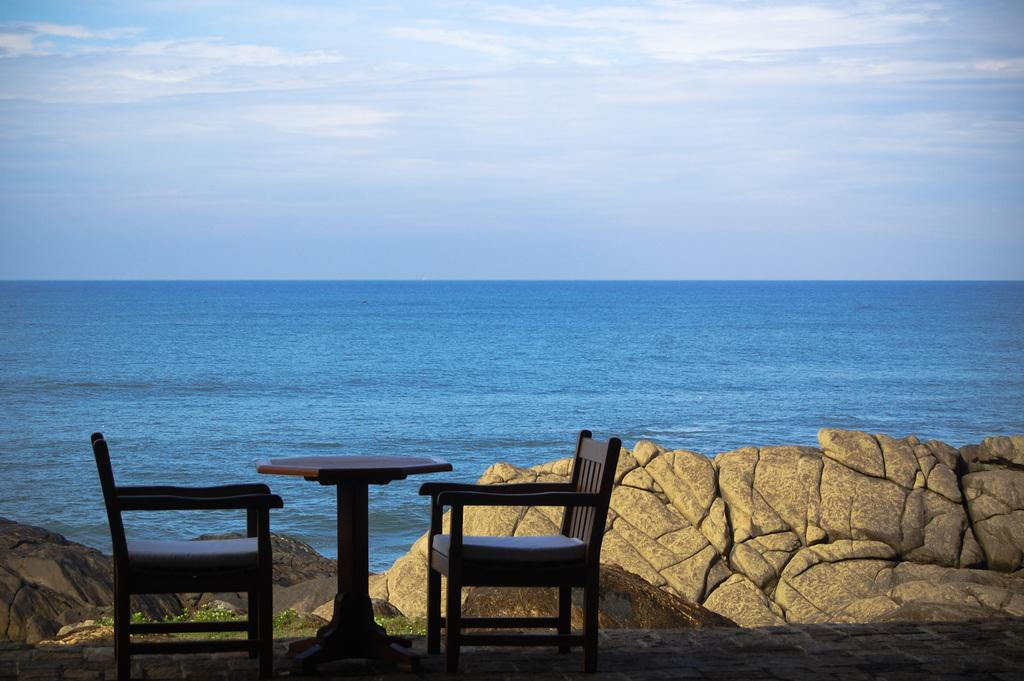What furniture is located on the left side of the image? There are two chairs on the left side of the image. What piece of furniture is in the middle of the image? There is a table in the image. What type of natural elements can be seen in the background of the image? Rocks and the beach are visible in the background of the image. What is visible at the top of the image? The sky is visible at the top of the image. Can you hear the horn of a passing boat in the image? There is no reference to a boat or a horn in the image, so it is not possible to answer that question. 